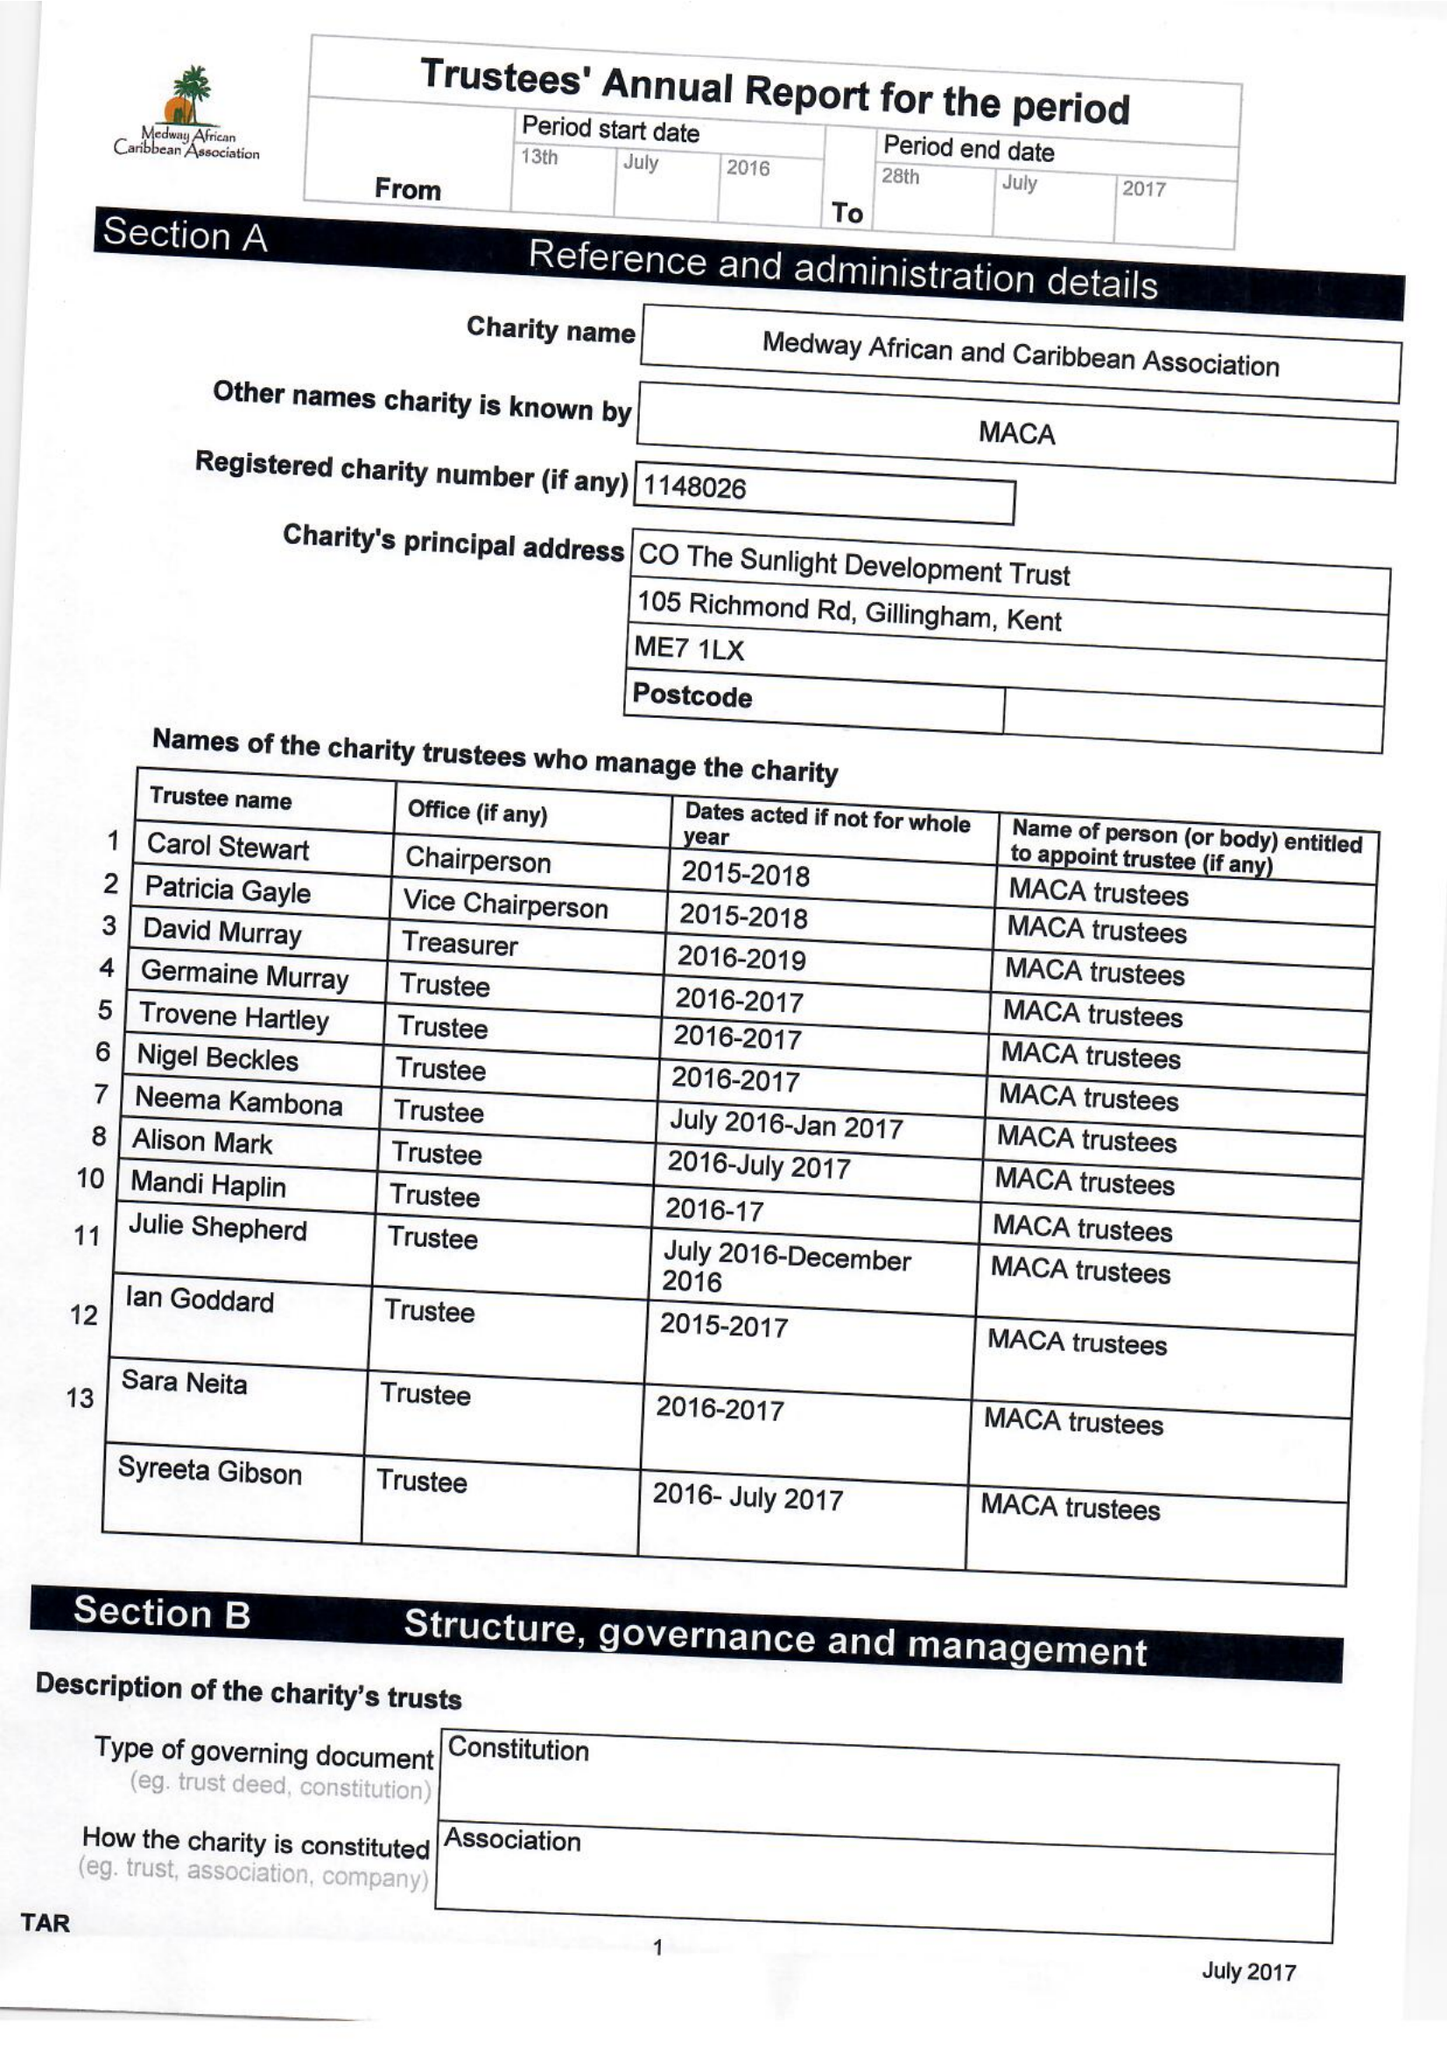What is the value for the address__post_town?
Answer the question using a single word or phrase. GILLINGHAM 